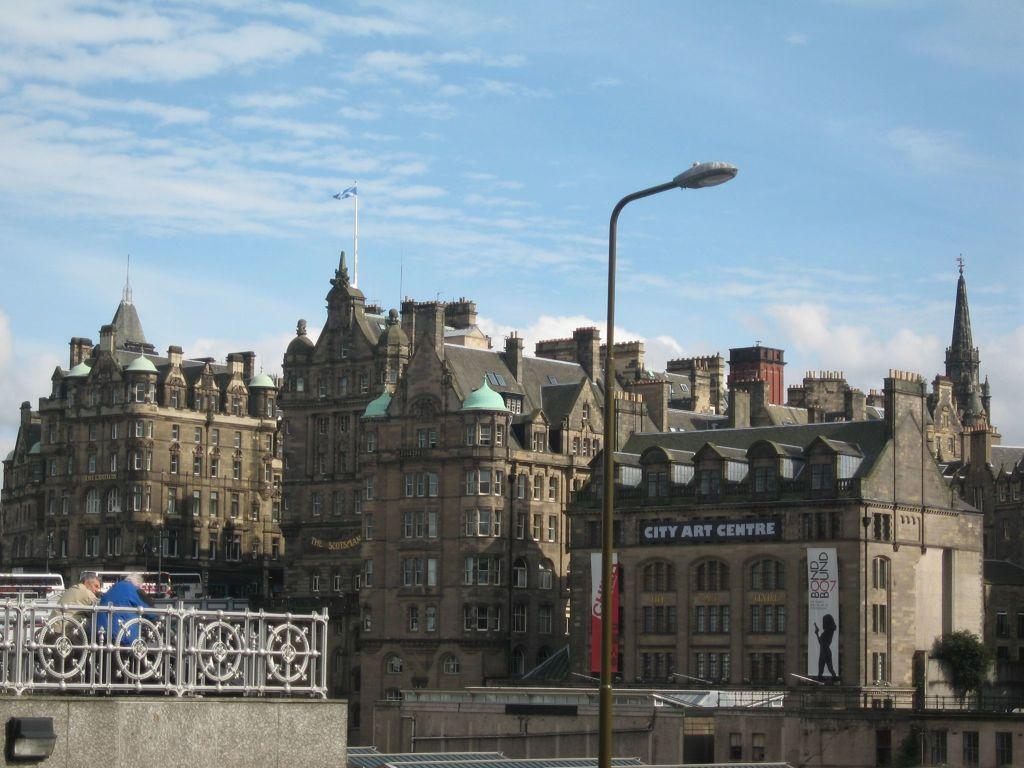What type of structures can be seen in the image? There are buildings in the image. Are there any people present in the image? Yes, there are people in the image. What is the pole in the image used for? The pole in the image is likely used to support the flag. Can you describe the flag in the image? There is a flag in the image. What type of vegetation is present in the image? There is a plant in the image. What is written on the boards in the image? The boards in the image have text on them. What is visible in the sky in the image? The sky is visible in the image, and there are clouds present. What type of bun is being used as a table in the image? There is no bun being used as a table in the image. What is the interest rate of the loan mentioned on the boards in the image? The boards in the image do not mention any loan or interest rate. 